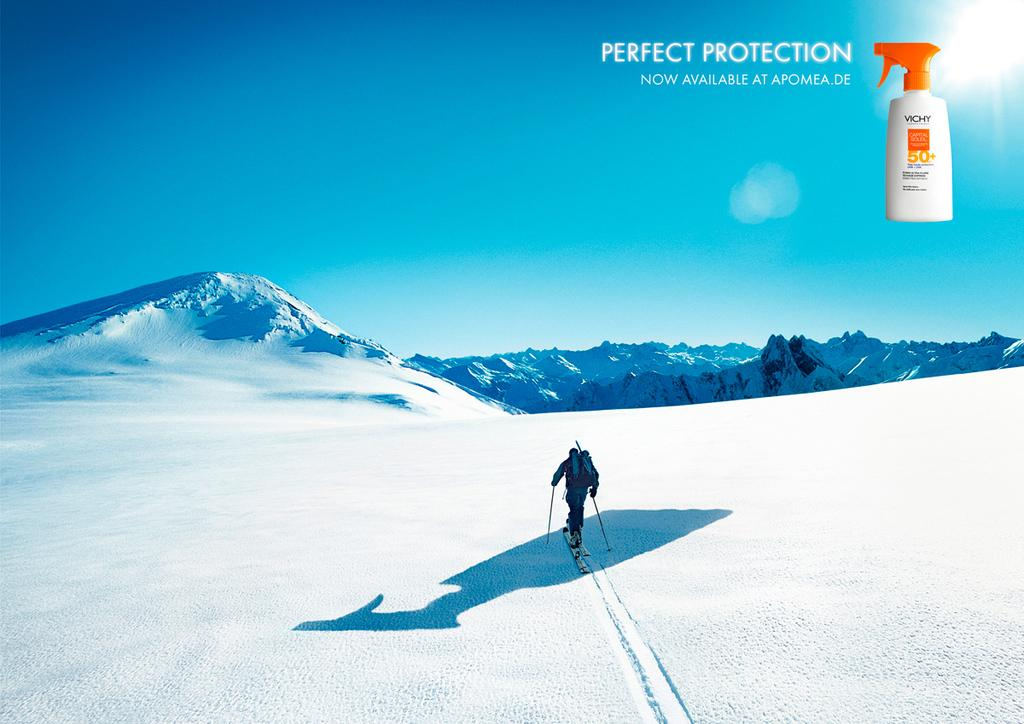<image>
Create a compact narrative representing the image presented. a person in the snow on skis and a perfect protection name in the top right 